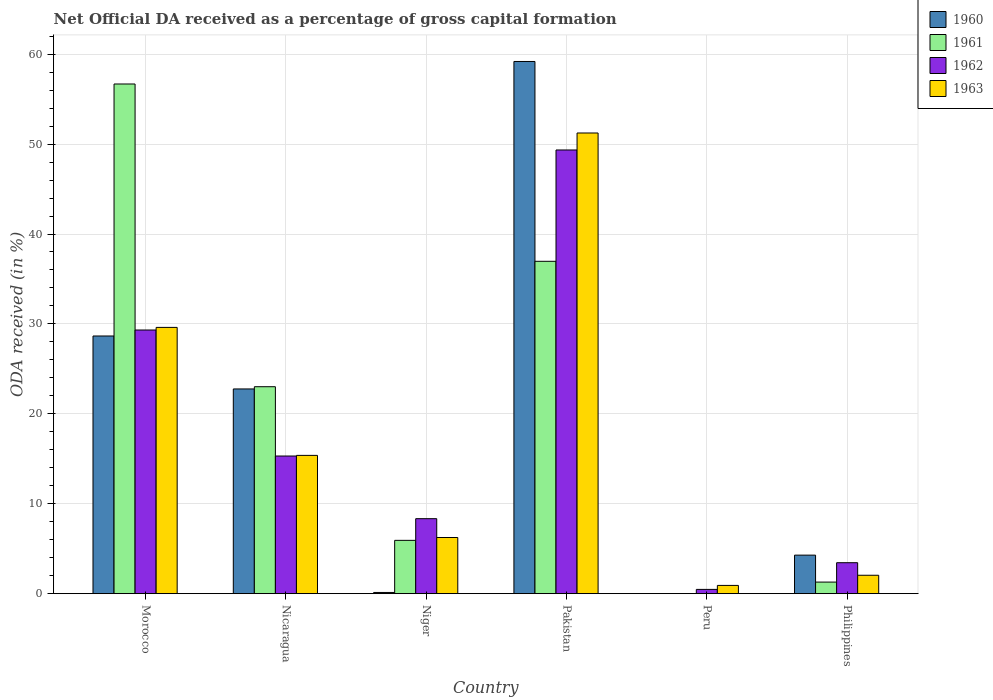How many groups of bars are there?
Ensure brevity in your answer.  6. Are the number of bars on each tick of the X-axis equal?
Offer a terse response. No. How many bars are there on the 2nd tick from the right?
Offer a very short reply. 2. What is the label of the 6th group of bars from the left?
Your answer should be very brief. Philippines. What is the net ODA received in 1962 in Nicaragua?
Make the answer very short. 15.31. Across all countries, what is the maximum net ODA received in 1963?
Your response must be concise. 51.24. Across all countries, what is the minimum net ODA received in 1963?
Ensure brevity in your answer.  0.92. What is the total net ODA received in 1962 in the graph?
Your response must be concise. 106.24. What is the difference between the net ODA received in 1960 in Niger and that in Pakistan?
Offer a terse response. -59.06. What is the difference between the net ODA received in 1962 in Pakistan and the net ODA received in 1961 in Peru?
Offer a terse response. 49.35. What is the average net ODA received in 1963 per country?
Keep it short and to the point. 17.57. What is the difference between the net ODA received of/in 1961 and net ODA received of/in 1963 in Niger?
Your answer should be very brief. -0.32. What is the ratio of the net ODA received in 1962 in Morocco to that in Philippines?
Give a very brief answer. 8.52. What is the difference between the highest and the second highest net ODA received in 1963?
Offer a very short reply. 21.62. What is the difference between the highest and the lowest net ODA received in 1960?
Ensure brevity in your answer.  59.19. In how many countries, is the net ODA received in 1962 greater than the average net ODA received in 1962 taken over all countries?
Ensure brevity in your answer.  2. Is the sum of the net ODA received in 1963 in Niger and Pakistan greater than the maximum net ODA received in 1960 across all countries?
Your response must be concise. No. Is it the case that in every country, the sum of the net ODA received in 1960 and net ODA received in 1963 is greater than the sum of net ODA received in 1961 and net ODA received in 1962?
Give a very brief answer. No. Is it the case that in every country, the sum of the net ODA received in 1960 and net ODA received in 1961 is greater than the net ODA received in 1962?
Provide a short and direct response. No. Are all the bars in the graph horizontal?
Provide a succinct answer. No. What is the difference between two consecutive major ticks on the Y-axis?
Provide a succinct answer. 10. Does the graph contain any zero values?
Give a very brief answer. Yes. Does the graph contain grids?
Give a very brief answer. Yes. What is the title of the graph?
Provide a succinct answer. Net Official DA received as a percentage of gross capital formation. What is the label or title of the Y-axis?
Give a very brief answer. ODA received (in %). What is the ODA received (in %) in 1960 in Morocco?
Ensure brevity in your answer.  28.66. What is the ODA received (in %) of 1961 in Morocco?
Your answer should be compact. 56.69. What is the ODA received (in %) in 1962 in Morocco?
Give a very brief answer. 29.32. What is the ODA received (in %) of 1963 in Morocco?
Make the answer very short. 29.61. What is the ODA received (in %) of 1960 in Nicaragua?
Offer a very short reply. 22.77. What is the ODA received (in %) of 1961 in Nicaragua?
Give a very brief answer. 23.02. What is the ODA received (in %) of 1962 in Nicaragua?
Ensure brevity in your answer.  15.31. What is the ODA received (in %) of 1963 in Nicaragua?
Offer a terse response. 15.38. What is the ODA received (in %) in 1960 in Niger?
Make the answer very short. 0.13. What is the ODA received (in %) in 1961 in Niger?
Offer a very short reply. 5.93. What is the ODA received (in %) in 1962 in Niger?
Your answer should be compact. 8.34. What is the ODA received (in %) in 1963 in Niger?
Your answer should be very brief. 6.25. What is the ODA received (in %) of 1960 in Pakistan?
Offer a very short reply. 59.19. What is the ODA received (in %) in 1961 in Pakistan?
Give a very brief answer. 36.96. What is the ODA received (in %) of 1962 in Pakistan?
Make the answer very short. 49.35. What is the ODA received (in %) in 1963 in Pakistan?
Offer a terse response. 51.24. What is the ODA received (in %) in 1960 in Peru?
Your response must be concise. 0. What is the ODA received (in %) in 1961 in Peru?
Ensure brevity in your answer.  0. What is the ODA received (in %) of 1962 in Peru?
Provide a succinct answer. 0.47. What is the ODA received (in %) of 1963 in Peru?
Give a very brief answer. 0.92. What is the ODA received (in %) in 1960 in Philippines?
Provide a short and direct response. 4.28. What is the ODA received (in %) in 1961 in Philippines?
Offer a terse response. 1.29. What is the ODA received (in %) of 1962 in Philippines?
Ensure brevity in your answer.  3.44. What is the ODA received (in %) in 1963 in Philippines?
Your answer should be very brief. 2.05. Across all countries, what is the maximum ODA received (in %) in 1960?
Your answer should be very brief. 59.19. Across all countries, what is the maximum ODA received (in %) in 1961?
Provide a short and direct response. 56.69. Across all countries, what is the maximum ODA received (in %) of 1962?
Offer a terse response. 49.35. Across all countries, what is the maximum ODA received (in %) in 1963?
Provide a succinct answer. 51.24. Across all countries, what is the minimum ODA received (in %) of 1961?
Keep it short and to the point. 0. Across all countries, what is the minimum ODA received (in %) of 1962?
Provide a succinct answer. 0.47. Across all countries, what is the minimum ODA received (in %) in 1963?
Offer a very short reply. 0.92. What is the total ODA received (in %) in 1960 in the graph?
Offer a terse response. 115.03. What is the total ODA received (in %) of 1961 in the graph?
Offer a terse response. 123.88. What is the total ODA received (in %) in 1962 in the graph?
Offer a very short reply. 106.24. What is the total ODA received (in %) in 1963 in the graph?
Offer a very short reply. 105.44. What is the difference between the ODA received (in %) in 1960 in Morocco and that in Nicaragua?
Offer a terse response. 5.89. What is the difference between the ODA received (in %) of 1961 in Morocco and that in Nicaragua?
Keep it short and to the point. 33.67. What is the difference between the ODA received (in %) of 1962 in Morocco and that in Nicaragua?
Ensure brevity in your answer.  14.02. What is the difference between the ODA received (in %) in 1963 in Morocco and that in Nicaragua?
Offer a terse response. 14.23. What is the difference between the ODA received (in %) in 1960 in Morocco and that in Niger?
Your answer should be very brief. 28.52. What is the difference between the ODA received (in %) in 1961 in Morocco and that in Niger?
Offer a terse response. 50.76. What is the difference between the ODA received (in %) in 1962 in Morocco and that in Niger?
Offer a terse response. 20.98. What is the difference between the ODA received (in %) of 1963 in Morocco and that in Niger?
Provide a succinct answer. 23.37. What is the difference between the ODA received (in %) in 1960 in Morocco and that in Pakistan?
Make the answer very short. -30.53. What is the difference between the ODA received (in %) in 1961 in Morocco and that in Pakistan?
Provide a short and direct response. 19.72. What is the difference between the ODA received (in %) in 1962 in Morocco and that in Pakistan?
Give a very brief answer. -20.02. What is the difference between the ODA received (in %) of 1963 in Morocco and that in Pakistan?
Ensure brevity in your answer.  -21.62. What is the difference between the ODA received (in %) of 1962 in Morocco and that in Peru?
Offer a very short reply. 28.85. What is the difference between the ODA received (in %) in 1963 in Morocco and that in Peru?
Ensure brevity in your answer.  28.7. What is the difference between the ODA received (in %) in 1960 in Morocco and that in Philippines?
Offer a very short reply. 24.37. What is the difference between the ODA received (in %) in 1961 in Morocco and that in Philippines?
Offer a terse response. 55.4. What is the difference between the ODA received (in %) in 1962 in Morocco and that in Philippines?
Ensure brevity in your answer.  25.88. What is the difference between the ODA received (in %) in 1963 in Morocco and that in Philippines?
Your answer should be very brief. 27.57. What is the difference between the ODA received (in %) in 1960 in Nicaragua and that in Niger?
Make the answer very short. 22.64. What is the difference between the ODA received (in %) of 1961 in Nicaragua and that in Niger?
Make the answer very short. 17.09. What is the difference between the ODA received (in %) in 1962 in Nicaragua and that in Niger?
Give a very brief answer. 6.97. What is the difference between the ODA received (in %) of 1963 in Nicaragua and that in Niger?
Your answer should be compact. 9.13. What is the difference between the ODA received (in %) in 1960 in Nicaragua and that in Pakistan?
Your response must be concise. -36.42. What is the difference between the ODA received (in %) in 1961 in Nicaragua and that in Pakistan?
Your answer should be compact. -13.95. What is the difference between the ODA received (in %) in 1962 in Nicaragua and that in Pakistan?
Keep it short and to the point. -34.04. What is the difference between the ODA received (in %) in 1963 in Nicaragua and that in Pakistan?
Provide a short and direct response. -35.86. What is the difference between the ODA received (in %) of 1962 in Nicaragua and that in Peru?
Your response must be concise. 14.83. What is the difference between the ODA received (in %) in 1963 in Nicaragua and that in Peru?
Offer a terse response. 14.46. What is the difference between the ODA received (in %) of 1960 in Nicaragua and that in Philippines?
Keep it short and to the point. 18.48. What is the difference between the ODA received (in %) in 1961 in Nicaragua and that in Philippines?
Give a very brief answer. 21.73. What is the difference between the ODA received (in %) of 1962 in Nicaragua and that in Philippines?
Offer a terse response. 11.87. What is the difference between the ODA received (in %) of 1963 in Nicaragua and that in Philippines?
Your answer should be compact. 13.33. What is the difference between the ODA received (in %) of 1960 in Niger and that in Pakistan?
Ensure brevity in your answer.  -59.06. What is the difference between the ODA received (in %) in 1961 in Niger and that in Pakistan?
Make the answer very short. -31.03. What is the difference between the ODA received (in %) in 1962 in Niger and that in Pakistan?
Make the answer very short. -41.01. What is the difference between the ODA received (in %) of 1963 in Niger and that in Pakistan?
Keep it short and to the point. -44.99. What is the difference between the ODA received (in %) of 1962 in Niger and that in Peru?
Provide a succinct answer. 7.87. What is the difference between the ODA received (in %) of 1963 in Niger and that in Peru?
Give a very brief answer. 5.33. What is the difference between the ODA received (in %) of 1960 in Niger and that in Philippines?
Your response must be concise. -4.15. What is the difference between the ODA received (in %) in 1961 in Niger and that in Philippines?
Your answer should be compact. 4.64. What is the difference between the ODA received (in %) of 1962 in Niger and that in Philippines?
Your response must be concise. 4.9. What is the difference between the ODA received (in %) in 1963 in Niger and that in Philippines?
Offer a very short reply. 4.2. What is the difference between the ODA received (in %) of 1962 in Pakistan and that in Peru?
Provide a short and direct response. 48.87. What is the difference between the ODA received (in %) of 1963 in Pakistan and that in Peru?
Make the answer very short. 50.32. What is the difference between the ODA received (in %) of 1960 in Pakistan and that in Philippines?
Give a very brief answer. 54.9. What is the difference between the ODA received (in %) in 1961 in Pakistan and that in Philippines?
Keep it short and to the point. 35.68. What is the difference between the ODA received (in %) in 1962 in Pakistan and that in Philippines?
Your response must be concise. 45.91. What is the difference between the ODA received (in %) of 1963 in Pakistan and that in Philippines?
Provide a short and direct response. 49.19. What is the difference between the ODA received (in %) in 1962 in Peru and that in Philippines?
Provide a succinct answer. -2.97. What is the difference between the ODA received (in %) of 1963 in Peru and that in Philippines?
Provide a succinct answer. -1.13. What is the difference between the ODA received (in %) in 1960 in Morocco and the ODA received (in %) in 1961 in Nicaragua?
Your answer should be compact. 5.64. What is the difference between the ODA received (in %) in 1960 in Morocco and the ODA received (in %) in 1962 in Nicaragua?
Your response must be concise. 13.35. What is the difference between the ODA received (in %) in 1960 in Morocco and the ODA received (in %) in 1963 in Nicaragua?
Keep it short and to the point. 13.28. What is the difference between the ODA received (in %) in 1961 in Morocco and the ODA received (in %) in 1962 in Nicaragua?
Offer a very short reply. 41.38. What is the difference between the ODA received (in %) of 1961 in Morocco and the ODA received (in %) of 1963 in Nicaragua?
Provide a short and direct response. 41.31. What is the difference between the ODA received (in %) of 1962 in Morocco and the ODA received (in %) of 1963 in Nicaragua?
Your answer should be compact. 13.95. What is the difference between the ODA received (in %) in 1960 in Morocco and the ODA received (in %) in 1961 in Niger?
Provide a short and direct response. 22.73. What is the difference between the ODA received (in %) of 1960 in Morocco and the ODA received (in %) of 1962 in Niger?
Your answer should be very brief. 20.32. What is the difference between the ODA received (in %) of 1960 in Morocco and the ODA received (in %) of 1963 in Niger?
Your answer should be compact. 22.41. What is the difference between the ODA received (in %) in 1961 in Morocco and the ODA received (in %) in 1962 in Niger?
Provide a succinct answer. 48.35. What is the difference between the ODA received (in %) in 1961 in Morocco and the ODA received (in %) in 1963 in Niger?
Keep it short and to the point. 50.44. What is the difference between the ODA received (in %) of 1962 in Morocco and the ODA received (in %) of 1963 in Niger?
Provide a short and direct response. 23.08. What is the difference between the ODA received (in %) of 1960 in Morocco and the ODA received (in %) of 1961 in Pakistan?
Your answer should be very brief. -8.31. What is the difference between the ODA received (in %) of 1960 in Morocco and the ODA received (in %) of 1962 in Pakistan?
Provide a succinct answer. -20.69. What is the difference between the ODA received (in %) of 1960 in Morocco and the ODA received (in %) of 1963 in Pakistan?
Give a very brief answer. -22.58. What is the difference between the ODA received (in %) in 1961 in Morocco and the ODA received (in %) in 1962 in Pakistan?
Provide a short and direct response. 7.34. What is the difference between the ODA received (in %) of 1961 in Morocco and the ODA received (in %) of 1963 in Pakistan?
Your answer should be very brief. 5.45. What is the difference between the ODA received (in %) in 1962 in Morocco and the ODA received (in %) in 1963 in Pakistan?
Provide a short and direct response. -21.91. What is the difference between the ODA received (in %) of 1960 in Morocco and the ODA received (in %) of 1962 in Peru?
Provide a short and direct response. 28.18. What is the difference between the ODA received (in %) of 1960 in Morocco and the ODA received (in %) of 1963 in Peru?
Make the answer very short. 27.74. What is the difference between the ODA received (in %) of 1961 in Morocco and the ODA received (in %) of 1962 in Peru?
Your response must be concise. 56.21. What is the difference between the ODA received (in %) of 1961 in Morocco and the ODA received (in %) of 1963 in Peru?
Your response must be concise. 55.77. What is the difference between the ODA received (in %) in 1962 in Morocco and the ODA received (in %) in 1963 in Peru?
Provide a succinct answer. 28.41. What is the difference between the ODA received (in %) in 1960 in Morocco and the ODA received (in %) in 1961 in Philippines?
Your answer should be very brief. 27.37. What is the difference between the ODA received (in %) in 1960 in Morocco and the ODA received (in %) in 1962 in Philippines?
Keep it short and to the point. 25.22. What is the difference between the ODA received (in %) of 1960 in Morocco and the ODA received (in %) of 1963 in Philippines?
Your answer should be compact. 26.61. What is the difference between the ODA received (in %) in 1961 in Morocco and the ODA received (in %) in 1962 in Philippines?
Keep it short and to the point. 53.24. What is the difference between the ODA received (in %) of 1961 in Morocco and the ODA received (in %) of 1963 in Philippines?
Your answer should be compact. 54.64. What is the difference between the ODA received (in %) in 1962 in Morocco and the ODA received (in %) in 1963 in Philippines?
Keep it short and to the point. 27.28. What is the difference between the ODA received (in %) in 1960 in Nicaragua and the ODA received (in %) in 1961 in Niger?
Your answer should be very brief. 16.84. What is the difference between the ODA received (in %) in 1960 in Nicaragua and the ODA received (in %) in 1962 in Niger?
Give a very brief answer. 14.43. What is the difference between the ODA received (in %) in 1960 in Nicaragua and the ODA received (in %) in 1963 in Niger?
Make the answer very short. 16.52. What is the difference between the ODA received (in %) in 1961 in Nicaragua and the ODA received (in %) in 1962 in Niger?
Give a very brief answer. 14.68. What is the difference between the ODA received (in %) of 1961 in Nicaragua and the ODA received (in %) of 1963 in Niger?
Ensure brevity in your answer.  16.77. What is the difference between the ODA received (in %) of 1962 in Nicaragua and the ODA received (in %) of 1963 in Niger?
Your response must be concise. 9.06. What is the difference between the ODA received (in %) of 1960 in Nicaragua and the ODA received (in %) of 1961 in Pakistan?
Your answer should be compact. -14.2. What is the difference between the ODA received (in %) in 1960 in Nicaragua and the ODA received (in %) in 1962 in Pakistan?
Ensure brevity in your answer.  -26.58. What is the difference between the ODA received (in %) of 1960 in Nicaragua and the ODA received (in %) of 1963 in Pakistan?
Your answer should be compact. -28.47. What is the difference between the ODA received (in %) in 1961 in Nicaragua and the ODA received (in %) in 1962 in Pakistan?
Keep it short and to the point. -26.33. What is the difference between the ODA received (in %) of 1961 in Nicaragua and the ODA received (in %) of 1963 in Pakistan?
Your response must be concise. -28.22. What is the difference between the ODA received (in %) in 1962 in Nicaragua and the ODA received (in %) in 1963 in Pakistan?
Give a very brief answer. -35.93. What is the difference between the ODA received (in %) in 1960 in Nicaragua and the ODA received (in %) in 1962 in Peru?
Provide a short and direct response. 22.29. What is the difference between the ODA received (in %) in 1960 in Nicaragua and the ODA received (in %) in 1963 in Peru?
Provide a short and direct response. 21.85. What is the difference between the ODA received (in %) of 1961 in Nicaragua and the ODA received (in %) of 1962 in Peru?
Provide a succinct answer. 22.54. What is the difference between the ODA received (in %) in 1961 in Nicaragua and the ODA received (in %) in 1963 in Peru?
Ensure brevity in your answer.  22.1. What is the difference between the ODA received (in %) of 1962 in Nicaragua and the ODA received (in %) of 1963 in Peru?
Keep it short and to the point. 14.39. What is the difference between the ODA received (in %) of 1960 in Nicaragua and the ODA received (in %) of 1961 in Philippines?
Your answer should be very brief. 21.48. What is the difference between the ODA received (in %) in 1960 in Nicaragua and the ODA received (in %) in 1962 in Philippines?
Your answer should be very brief. 19.33. What is the difference between the ODA received (in %) of 1960 in Nicaragua and the ODA received (in %) of 1963 in Philippines?
Your answer should be compact. 20.72. What is the difference between the ODA received (in %) in 1961 in Nicaragua and the ODA received (in %) in 1962 in Philippines?
Give a very brief answer. 19.58. What is the difference between the ODA received (in %) of 1961 in Nicaragua and the ODA received (in %) of 1963 in Philippines?
Give a very brief answer. 20.97. What is the difference between the ODA received (in %) of 1962 in Nicaragua and the ODA received (in %) of 1963 in Philippines?
Ensure brevity in your answer.  13.26. What is the difference between the ODA received (in %) of 1960 in Niger and the ODA received (in %) of 1961 in Pakistan?
Make the answer very short. -36.83. What is the difference between the ODA received (in %) of 1960 in Niger and the ODA received (in %) of 1962 in Pakistan?
Offer a very short reply. -49.21. What is the difference between the ODA received (in %) of 1960 in Niger and the ODA received (in %) of 1963 in Pakistan?
Your response must be concise. -51.1. What is the difference between the ODA received (in %) of 1961 in Niger and the ODA received (in %) of 1962 in Pakistan?
Make the answer very short. -43.42. What is the difference between the ODA received (in %) in 1961 in Niger and the ODA received (in %) in 1963 in Pakistan?
Provide a short and direct response. -45.31. What is the difference between the ODA received (in %) of 1962 in Niger and the ODA received (in %) of 1963 in Pakistan?
Offer a very short reply. -42.9. What is the difference between the ODA received (in %) in 1960 in Niger and the ODA received (in %) in 1962 in Peru?
Offer a very short reply. -0.34. What is the difference between the ODA received (in %) in 1960 in Niger and the ODA received (in %) in 1963 in Peru?
Give a very brief answer. -0.78. What is the difference between the ODA received (in %) of 1961 in Niger and the ODA received (in %) of 1962 in Peru?
Offer a terse response. 5.46. What is the difference between the ODA received (in %) of 1961 in Niger and the ODA received (in %) of 1963 in Peru?
Give a very brief answer. 5.01. What is the difference between the ODA received (in %) of 1962 in Niger and the ODA received (in %) of 1963 in Peru?
Provide a short and direct response. 7.42. What is the difference between the ODA received (in %) of 1960 in Niger and the ODA received (in %) of 1961 in Philippines?
Make the answer very short. -1.15. What is the difference between the ODA received (in %) in 1960 in Niger and the ODA received (in %) in 1962 in Philippines?
Ensure brevity in your answer.  -3.31. What is the difference between the ODA received (in %) in 1960 in Niger and the ODA received (in %) in 1963 in Philippines?
Keep it short and to the point. -1.91. What is the difference between the ODA received (in %) in 1961 in Niger and the ODA received (in %) in 1962 in Philippines?
Give a very brief answer. 2.49. What is the difference between the ODA received (in %) in 1961 in Niger and the ODA received (in %) in 1963 in Philippines?
Ensure brevity in your answer.  3.88. What is the difference between the ODA received (in %) in 1962 in Niger and the ODA received (in %) in 1963 in Philippines?
Provide a succinct answer. 6.29. What is the difference between the ODA received (in %) of 1960 in Pakistan and the ODA received (in %) of 1962 in Peru?
Provide a succinct answer. 58.71. What is the difference between the ODA received (in %) of 1960 in Pakistan and the ODA received (in %) of 1963 in Peru?
Ensure brevity in your answer.  58.27. What is the difference between the ODA received (in %) of 1961 in Pakistan and the ODA received (in %) of 1962 in Peru?
Offer a very short reply. 36.49. What is the difference between the ODA received (in %) of 1961 in Pakistan and the ODA received (in %) of 1963 in Peru?
Offer a very short reply. 36.05. What is the difference between the ODA received (in %) in 1962 in Pakistan and the ODA received (in %) in 1963 in Peru?
Offer a very short reply. 48.43. What is the difference between the ODA received (in %) in 1960 in Pakistan and the ODA received (in %) in 1961 in Philippines?
Make the answer very short. 57.9. What is the difference between the ODA received (in %) of 1960 in Pakistan and the ODA received (in %) of 1962 in Philippines?
Offer a terse response. 55.75. What is the difference between the ODA received (in %) of 1960 in Pakistan and the ODA received (in %) of 1963 in Philippines?
Keep it short and to the point. 57.14. What is the difference between the ODA received (in %) in 1961 in Pakistan and the ODA received (in %) in 1962 in Philippines?
Provide a short and direct response. 33.52. What is the difference between the ODA received (in %) in 1961 in Pakistan and the ODA received (in %) in 1963 in Philippines?
Ensure brevity in your answer.  34.92. What is the difference between the ODA received (in %) of 1962 in Pakistan and the ODA received (in %) of 1963 in Philippines?
Offer a terse response. 47.3. What is the difference between the ODA received (in %) in 1962 in Peru and the ODA received (in %) in 1963 in Philippines?
Ensure brevity in your answer.  -1.57. What is the average ODA received (in %) in 1960 per country?
Provide a short and direct response. 19.17. What is the average ODA received (in %) in 1961 per country?
Provide a short and direct response. 20.65. What is the average ODA received (in %) of 1962 per country?
Provide a succinct answer. 17.71. What is the average ODA received (in %) of 1963 per country?
Your answer should be compact. 17.57. What is the difference between the ODA received (in %) in 1960 and ODA received (in %) in 1961 in Morocco?
Offer a very short reply. -28.03. What is the difference between the ODA received (in %) in 1960 and ODA received (in %) in 1962 in Morocco?
Your answer should be compact. -0.67. What is the difference between the ODA received (in %) in 1960 and ODA received (in %) in 1963 in Morocco?
Your answer should be very brief. -0.96. What is the difference between the ODA received (in %) in 1961 and ODA received (in %) in 1962 in Morocco?
Your answer should be compact. 27.36. What is the difference between the ODA received (in %) in 1961 and ODA received (in %) in 1963 in Morocco?
Give a very brief answer. 27.07. What is the difference between the ODA received (in %) in 1962 and ODA received (in %) in 1963 in Morocco?
Your response must be concise. -0.29. What is the difference between the ODA received (in %) in 1960 and ODA received (in %) in 1961 in Nicaragua?
Your response must be concise. -0.25. What is the difference between the ODA received (in %) in 1960 and ODA received (in %) in 1962 in Nicaragua?
Your answer should be compact. 7.46. What is the difference between the ODA received (in %) of 1960 and ODA received (in %) of 1963 in Nicaragua?
Provide a succinct answer. 7.39. What is the difference between the ODA received (in %) in 1961 and ODA received (in %) in 1962 in Nicaragua?
Provide a short and direct response. 7.71. What is the difference between the ODA received (in %) in 1961 and ODA received (in %) in 1963 in Nicaragua?
Ensure brevity in your answer.  7.64. What is the difference between the ODA received (in %) in 1962 and ODA received (in %) in 1963 in Nicaragua?
Give a very brief answer. -0.07. What is the difference between the ODA received (in %) of 1960 and ODA received (in %) of 1961 in Niger?
Your answer should be very brief. -5.8. What is the difference between the ODA received (in %) in 1960 and ODA received (in %) in 1962 in Niger?
Make the answer very short. -8.21. What is the difference between the ODA received (in %) of 1960 and ODA received (in %) of 1963 in Niger?
Offer a terse response. -6.11. What is the difference between the ODA received (in %) of 1961 and ODA received (in %) of 1962 in Niger?
Your response must be concise. -2.41. What is the difference between the ODA received (in %) in 1961 and ODA received (in %) in 1963 in Niger?
Provide a short and direct response. -0.32. What is the difference between the ODA received (in %) in 1962 and ODA received (in %) in 1963 in Niger?
Your answer should be very brief. 2.09. What is the difference between the ODA received (in %) of 1960 and ODA received (in %) of 1961 in Pakistan?
Your answer should be compact. 22.22. What is the difference between the ODA received (in %) in 1960 and ODA received (in %) in 1962 in Pakistan?
Your answer should be compact. 9.84. What is the difference between the ODA received (in %) in 1960 and ODA received (in %) in 1963 in Pakistan?
Provide a succinct answer. 7.95. What is the difference between the ODA received (in %) of 1961 and ODA received (in %) of 1962 in Pakistan?
Provide a succinct answer. -12.38. What is the difference between the ODA received (in %) of 1961 and ODA received (in %) of 1963 in Pakistan?
Give a very brief answer. -14.27. What is the difference between the ODA received (in %) of 1962 and ODA received (in %) of 1963 in Pakistan?
Your answer should be very brief. -1.89. What is the difference between the ODA received (in %) of 1962 and ODA received (in %) of 1963 in Peru?
Offer a terse response. -0.44. What is the difference between the ODA received (in %) in 1960 and ODA received (in %) in 1961 in Philippines?
Provide a succinct answer. 3. What is the difference between the ODA received (in %) of 1960 and ODA received (in %) of 1962 in Philippines?
Offer a very short reply. 0.84. What is the difference between the ODA received (in %) in 1960 and ODA received (in %) in 1963 in Philippines?
Offer a very short reply. 2.24. What is the difference between the ODA received (in %) of 1961 and ODA received (in %) of 1962 in Philippines?
Offer a terse response. -2.15. What is the difference between the ODA received (in %) in 1961 and ODA received (in %) in 1963 in Philippines?
Provide a succinct answer. -0.76. What is the difference between the ODA received (in %) in 1962 and ODA received (in %) in 1963 in Philippines?
Offer a terse response. 1.4. What is the ratio of the ODA received (in %) in 1960 in Morocco to that in Nicaragua?
Provide a short and direct response. 1.26. What is the ratio of the ODA received (in %) of 1961 in Morocco to that in Nicaragua?
Give a very brief answer. 2.46. What is the ratio of the ODA received (in %) in 1962 in Morocco to that in Nicaragua?
Your answer should be very brief. 1.92. What is the ratio of the ODA received (in %) in 1963 in Morocco to that in Nicaragua?
Keep it short and to the point. 1.93. What is the ratio of the ODA received (in %) in 1960 in Morocco to that in Niger?
Provide a short and direct response. 215.63. What is the ratio of the ODA received (in %) of 1961 in Morocco to that in Niger?
Your response must be concise. 9.56. What is the ratio of the ODA received (in %) of 1962 in Morocco to that in Niger?
Make the answer very short. 3.52. What is the ratio of the ODA received (in %) in 1963 in Morocco to that in Niger?
Offer a terse response. 4.74. What is the ratio of the ODA received (in %) of 1960 in Morocco to that in Pakistan?
Provide a short and direct response. 0.48. What is the ratio of the ODA received (in %) of 1961 in Morocco to that in Pakistan?
Your response must be concise. 1.53. What is the ratio of the ODA received (in %) of 1962 in Morocco to that in Pakistan?
Give a very brief answer. 0.59. What is the ratio of the ODA received (in %) of 1963 in Morocco to that in Pakistan?
Keep it short and to the point. 0.58. What is the ratio of the ODA received (in %) of 1962 in Morocco to that in Peru?
Your answer should be very brief. 61.84. What is the ratio of the ODA received (in %) of 1963 in Morocco to that in Peru?
Ensure brevity in your answer.  32.28. What is the ratio of the ODA received (in %) in 1960 in Morocco to that in Philippines?
Your answer should be very brief. 6.69. What is the ratio of the ODA received (in %) in 1961 in Morocco to that in Philippines?
Make the answer very short. 44.03. What is the ratio of the ODA received (in %) in 1962 in Morocco to that in Philippines?
Your response must be concise. 8.52. What is the ratio of the ODA received (in %) of 1963 in Morocco to that in Philippines?
Give a very brief answer. 14.47. What is the ratio of the ODA received (in %) of 1960 in Nicaragua to that in Niger?
Keep it short and to the point. 171.32. What is the ratio of the ODA received (in %) in 1961 in Nicaragua to that in Niger?
Ensure brevity in your answer.  3.88. What is the ratio of the ODA received (in %) of 1962 in Nicaragua to that in Niger?
Keep it short and to the point. 1.84. What is the ratio of the ODA received (in %) of 1963 in Nicaragua to that in Niger?
Offer a terse response. 2.46. What is the ratio of the ODA received (in %) in 1960 in Nicaragua to that in Pakistan?
Offer a terse response. 0.38. What is the ratio of the ODA received (in %) in 1961 in Nicaragua to that in Pakistan?
Your response must be concise. 0.62. What is the ratio of the ODA received (in %) in 1962 in Nicaragua to that in Pakistan?
Give a very brief answer. 0.31. What is the ratio of the ODA received (in %) in 1963 in Nicaragua to that in Pakistan?
Provide a short and direct response. 0.3. What is the ratio of the ODA received (in %) of 1962 in Nicaragua to that in Peru?
Offer a very short reply. 32.28. What is the ratio of the ODA received (in %) in 1963 in Nicaragua to that in Peru?
Your answer should be very brief. 16.76. What is the ratio of the ODA received (in %) of 1960 in Nicaragua to that in Philippines?
Keep it short and to the point. 5.31. What is the ratio of the ODA received (in %) of 1961 in Nicaragua to that in Philippines?
Your answer should be very brief. 17.88. What is the ratio of the ODA received (in %) of 1962 in Nicaragua to that in Philippines?
Provide a succinct answer. 4.45. What is the ratio of the ODA received (in %) of 1963 in Nicaragua to that in Philippines?
Your answer should be compact. 7.52. What is the ratio of the ODA received (in %) in 1960 in Niger to that in Pakistan?
Offer a terse response. 0. What is the ratio of the ODA received (in %) in 1961 in Niger to that in Pakistan?
Offer a very short reply. 0.16. What is the ratio of the ODA received (in %) in 1962 in Niger to that in Pakistan?
Your answer should be compact. 0.17. What is the ratio of the ODA received (in %) in 1963 in Niger to that in Pakistan?
Your response must be concise. 0.12. What is the ratio of the ODA received (in %) of 1962 in Niger to that in Peru?
Offer a terse response. 17.59. What is the ratio of the ODA received (in %) of 1963 in Niger to that in Peru?
Your response must be concise. 6.81. What is the ratio of the ODA received (in %) in 1960 in Niger to that in Philippines?
Your answer should be very brief. 0.03. What is the ratio of the ODA received (in %) in 1961 in Niger to that in Philippines?
Provide a short and direct response. 4.61. What is the ratio of the ODA received (in %) in 1962 in Niger to that in Philippines?
Your answer should be compact. 2.42. What is the ratio of the ODA received (in %) in 1963 in Niger to that in Philippines?
Your response must be concise. 3.05. What is the ratio of the ODA received (in %) of 1962 in Pakistan to that in Peru?
Offer a very short reply. 104.06. What is the ratio of the ODA received (in %) of 1963 in Pakistan to that in Peru?
Ensure brevity in your answer.  55.85. What is the ratio of the ODA received (in %) in 1960 in Pakistan to that in Philippines?
Ensure brevity in your answer.  13.82. What is the ratio of the ODA received (in %) of 1961 in Pakistan to that in Philippines?
Your answer should be very brief. 28.71. What is the ratio of the ODA received (in %) of 1962 in Pakistan to that in Philippines?
Keep it short and to the point. 14.34. What is the ratio of the ODA received (in %) of 1963 in Pakistan to that in Philippines?
Provide a succinct answer. 25.04. What is the ratio of the ODA received (in %) of 1962 in Peru to that in Philippines?
Ensure brevity in your answer.  0.14. What is the ratio of the ODA received (in %) in 1963 in Peru to that in Philippines?
Make the answer very short. 0.45. What is the difference between the highest and the second highest ODA received (in %) in 1960?
Make the answer very short. 30.53. What is the difference between the highest and the second highest ODA received (in %) in 1961?
Keep it short and to the point. 19.72. What is the difference between the highest and the second highest ODA received (in %) in 1962?
Provide a short and direct response. 20.02. What is the difference between the highest and the second highest ODA received (in %) of 1963?
Offer a terse response. 21.62. What is the difference between the highest and the lowest ODA received (in %) of 1960?
Keep it short and to the point. 59.19. What is the difference between the highest and the lowest ODA received (in %) in 1961?
Provide a succinct answer. 56.69. What is the difference between the highest and the lowest ODA received (in %) of 1962?
Provide a succinct answer. 48.87. What is the difference between the highest and the lowest ODA received (in %) in 1963?
Offer a very short reply. 50.32. 